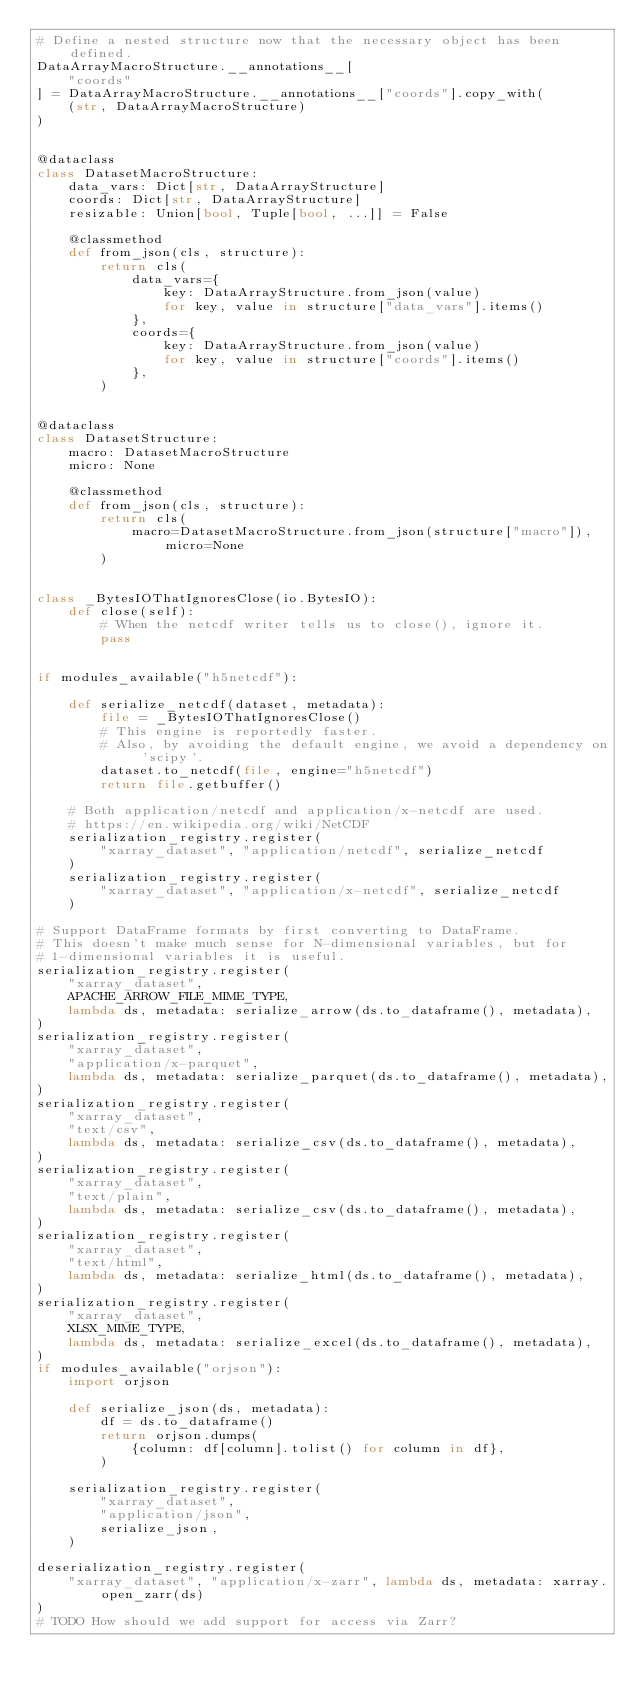<code> <loc_0><loc_0><loc_500><loc_500><_Python_># Define a nested structure now that the necessary object has been defined.
DataArrayMacroStructure.__annotations__[
    "coords"
] = DataArrayMacroStructure.__annotations__["coords"].copy_with(
    (str, DataArrayMacroStructure)
)


@dataclass
class DatasetMacroStructure:
    data_vars: Dict[str, DataArrayStructure]
    coords: Dict[str, DataArrayStructure]
    resizable: Union[bool, Tuple[bool, ...]] = False

    @classmethod
    def from_json(cls, structure):
        return cls(
            data_vars={
                key: DataArrayStructure.from_json(value)
                for key, value in structure["data_vars"].items()
            },
            coords={
                key: DataArrayStructure.from_json(value)
                for key, value in structure["coords"].items()
            },
        )


@dataclass
class DatasetStructure:
    macro: DatasetMacroStructure
    micro: None

    @classmethod
    def from_json(cls, structure):
        return cls(
            macro=DatasetMacroStructure.from_json(structure["macro"]), micro=None
        )


class _BytesIOThatIgnoresClose(io.BytesIO):
    def close(self):
        # When the netcdf writer tells us to close(), ignore it.
        pass


if modules_available("h5netcdf"):

    def serialize_netcdf(dataset, metadata):
        file = _BytesIOThatIgnoresClose()
        # This engine is reportedly faster.
        # Also, by avoiding the default engine, we avoid a dependency on 'scipy'.
        dataset.to_netcdf(file, engine="h5netcdf")
        return file.getbuffer()

    # Both application/netcdf and application/x-netcdf are used.
    # https://en.wikipedia.org/wiki/NetCDF
    serialization_registry.register(
        "xarray_dataset", "application/netcdf", serialize_netcdf
    )
    serialization_registry.register(
        "xarray_dataset", "application/x-netcdf", serialize_netcdf
    )

# Support DataFrame formats by first converting to DataFrame.
# This doesn't make much sense for N-dimensional variables, but for
# 1-dimensional variables it is useful.
serialization_registry.register(
    "xarray_dataset",
    APACHE_ARROW_FILE_MIME_TYPE,
    lambda ds, metadata: serialize_arrow(ds.to_dataframe(), metadata),
)
serialization_registry.register(
    "xarray_dataset",
    "application/x-parquet",
    lambda ds, metadata: serialize_parquet(ds.to_dataframe(), metadata),
)
serialization_registry.register(
    "xarray_dataset",
    "text/csv",
    lambda ds, metadata: serialize_csv(ds.to_dataframe(), metadata),
)
serialization_registry.register(
    "xarray_dataset",
    "text/plain",
    lambda ds, metadata: serialize_csv(ds.to_dataframe(), metadata),
)
serialization_registry.register(
    "xarray_dataset",
    "text/html",
    lambda ds, metadata: serialize_html(ds.to_dataframe(), metadata),
)
serialization_registry.register(
    "xarray_dataset",
    XLSX_MIME_TYPE,
    lambda ds, metadata: serialize_excel(ds.to_dataframe(), metadata),
)
if modules_available("orjson"):
    import orjson

    def serialize_json(ds, metadata):
        df = ds.to_dataframe()
        return orjson.dumps(
            {column: df[column].tolist() for column in df},
        )

    serialization_registry.register(
        "xarray_dataset",
        "application/json",
        serialize_json,
    )

deserialization_registry.register(
    "xarray_dataset", "application/x-zarr", lambda ds, metadata: xarray.open_zarr(ds)
)
# TODO How should we add support for access via Zarr?
</code> 